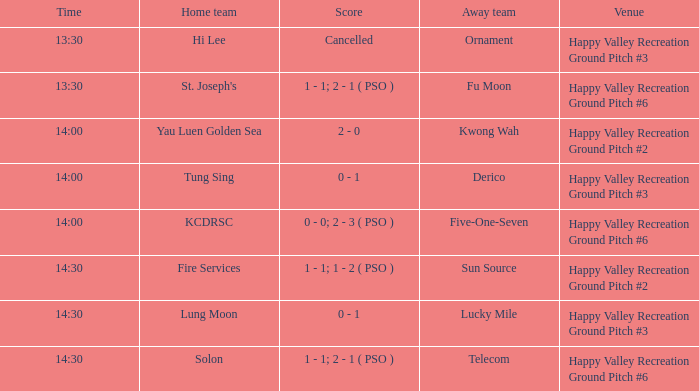What is the venue of the match with a 14:30 time and sun source as the away team? Happy Valley Recreation Ground Pitch #2. 